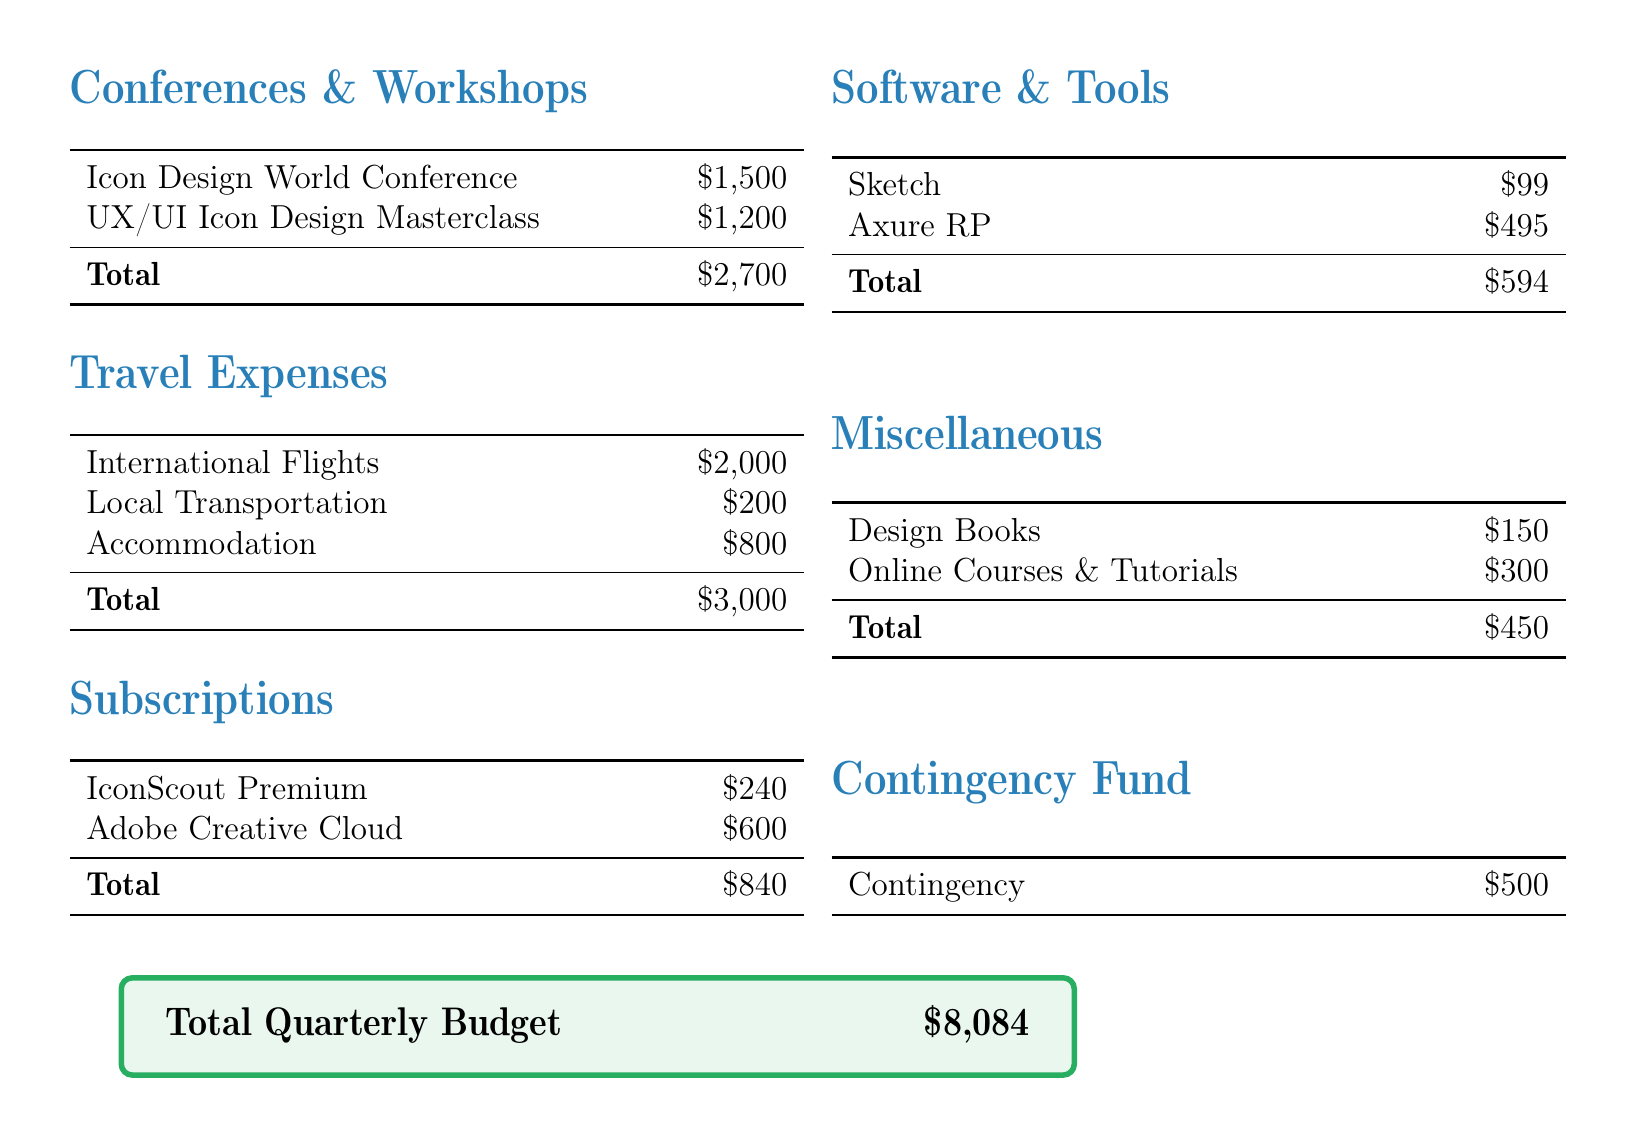What is the total budget for conferences and workshops? The total budget for conferences and workshops is the sum of all listed expenses in that section, which is $1,500 + $1,200.
Answer: $2,700 What is the expense for local transportation? The expense for local transportation is clearly stated in the travel expenses section.
Answer: $200 How much is allocated for Sketch software? The amount allocated for Sketch is specified under the software and tools section.
Answer: $99 What is the total amount for subscriptions? The total for subscriptions is the sum of the two subscriptions listed, which is $240 + $600.
Answer: $840 What is the contingency fund amount? The document specifically lists the contingency fund as a separate item.
Answer: $500 What is the total quarterly budget? The total quarterly budget is provided at the end of the document and encompasses all sections.
Answer: $8,084 How much is spent on design books? The cost of design books is included in the miscellaneous section.
Answer: $150 Which conference has the highest expense? The document lists various conferences and workshops with their respective costs, identifying the highest one.
Answer: Icon Design World Conference 